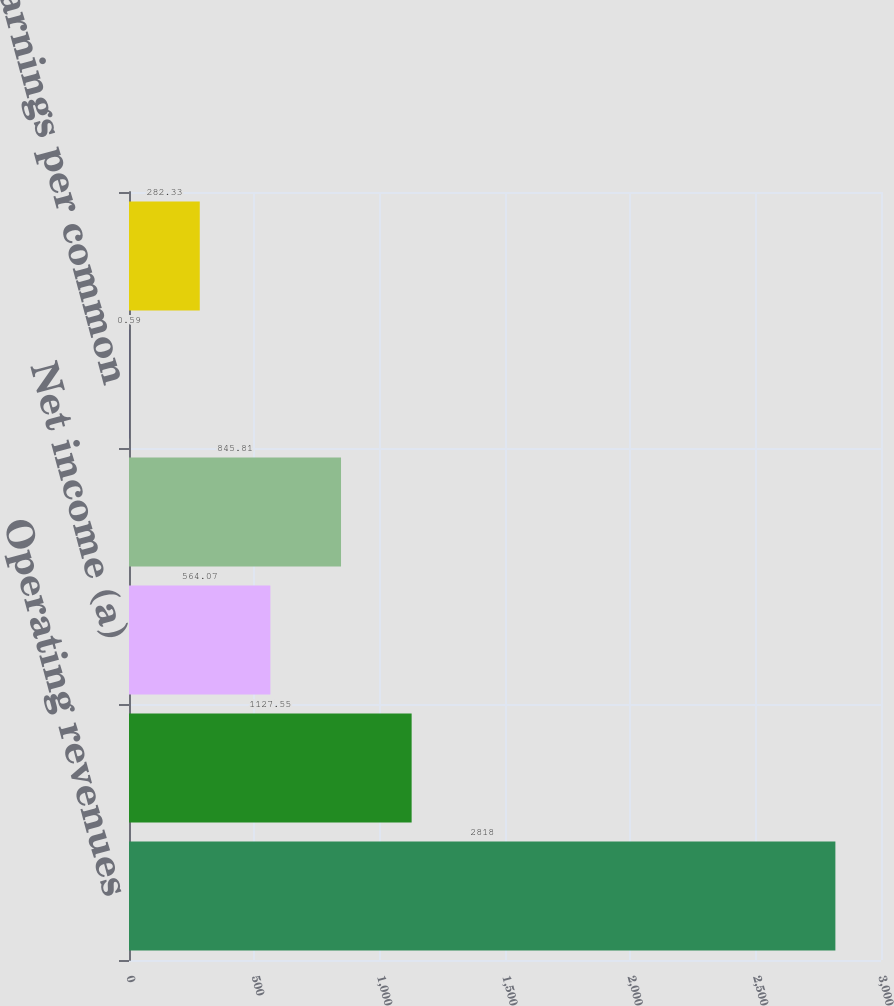Convert chart to OTSL. <chart><loc_0><loc_0><loc_500><loc_500><bar_chart><fcel>Operating revenues<fcel>Operating income<fcel>Net income (a)<fcel>Net income for common stock<fcel>Basic earnings per common<fcel>Diluted earnings per common<nl><fcel>2818<fcel>1127.55<fcel>564.07<fcel>845.81<fcel>0.59<fcel>282.33<nl></chart> 